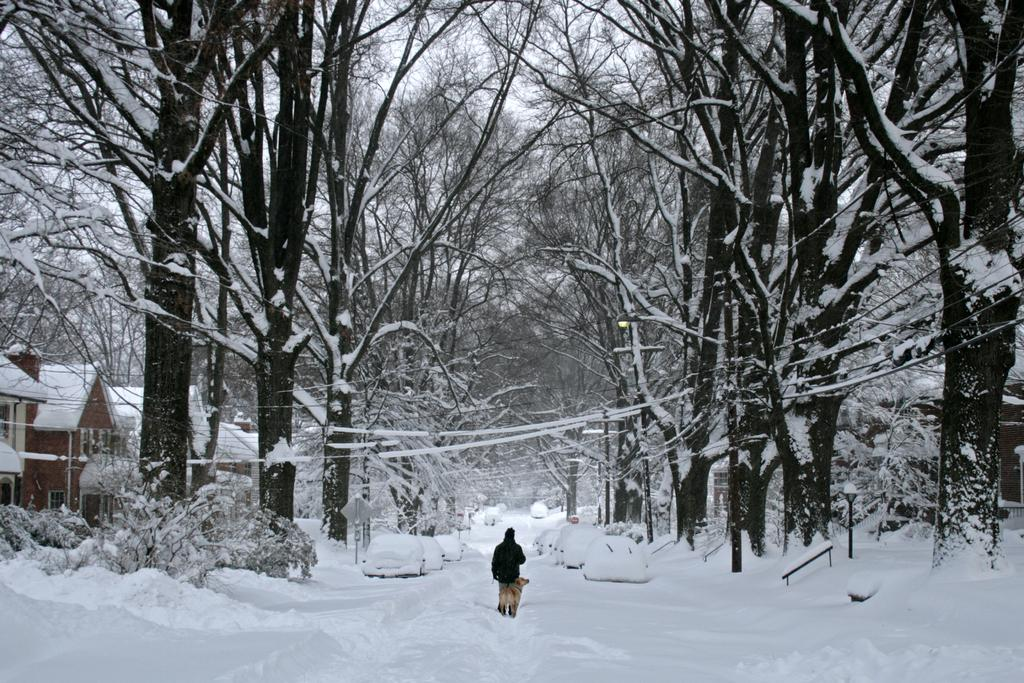What type of natural elements can be seen in the image? There are many trees and houseplants in the image. What man-made objects are visible in the image? There are cars and a sign pole in the image. What is the condition of the elements in the image? All elements mentioned are covered with snow. Can you describe the person in the image? A man is standing in the middle of the image. What type of advertisement can be seen on the boats in the image? There are no boats present in the image, so there is no advertisement to be seen on them. 